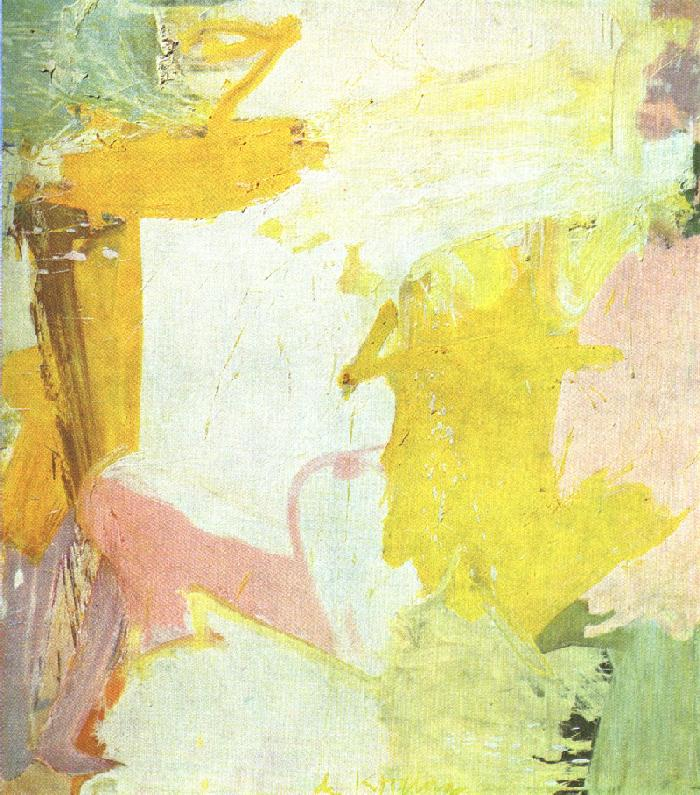Describe a realistic scene you imagine might have inspired this abstract piece. I imagine this abstract piece was inspired by a serene morning in a park. The artist might have been sitting on a bench, observing the golden sunlight filtering through the trees, creating a play of light and shadows on the grassy ground. Nearby, a garden full of blooming flowers in soft pinks and whites adds splashes of color to the scenery. As children play and birds sing, the artist captures the essence of this moment of calm and joy, translating it into flowing strokes of pastel colors on the canvas. 
Based on this painting, describe a short realistic scenario in one sentence. This painting captures the fleeting moment of early morning light gently illuminating a tranquil garden, suffusing everything with a serene pastel glow. 